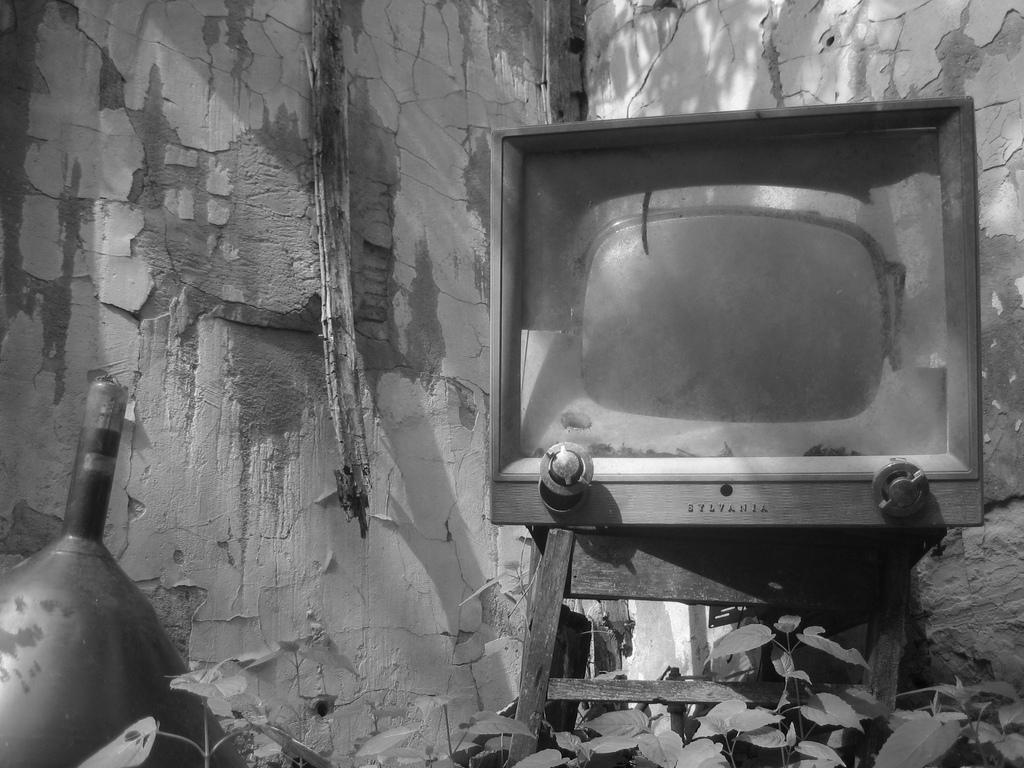What electronic device is visible in the image? There is a TV in the image. What type of living organisms can be seen in the image? Plants are visible in the image. What type of structure is present in the image? There is a wall in the image. What is the color scheme of the image? The image is black and white in color. What time of day is it in the image, and how many women are present? The image is black and white, so it is not possible to determine the time of day or the presence of any women. 